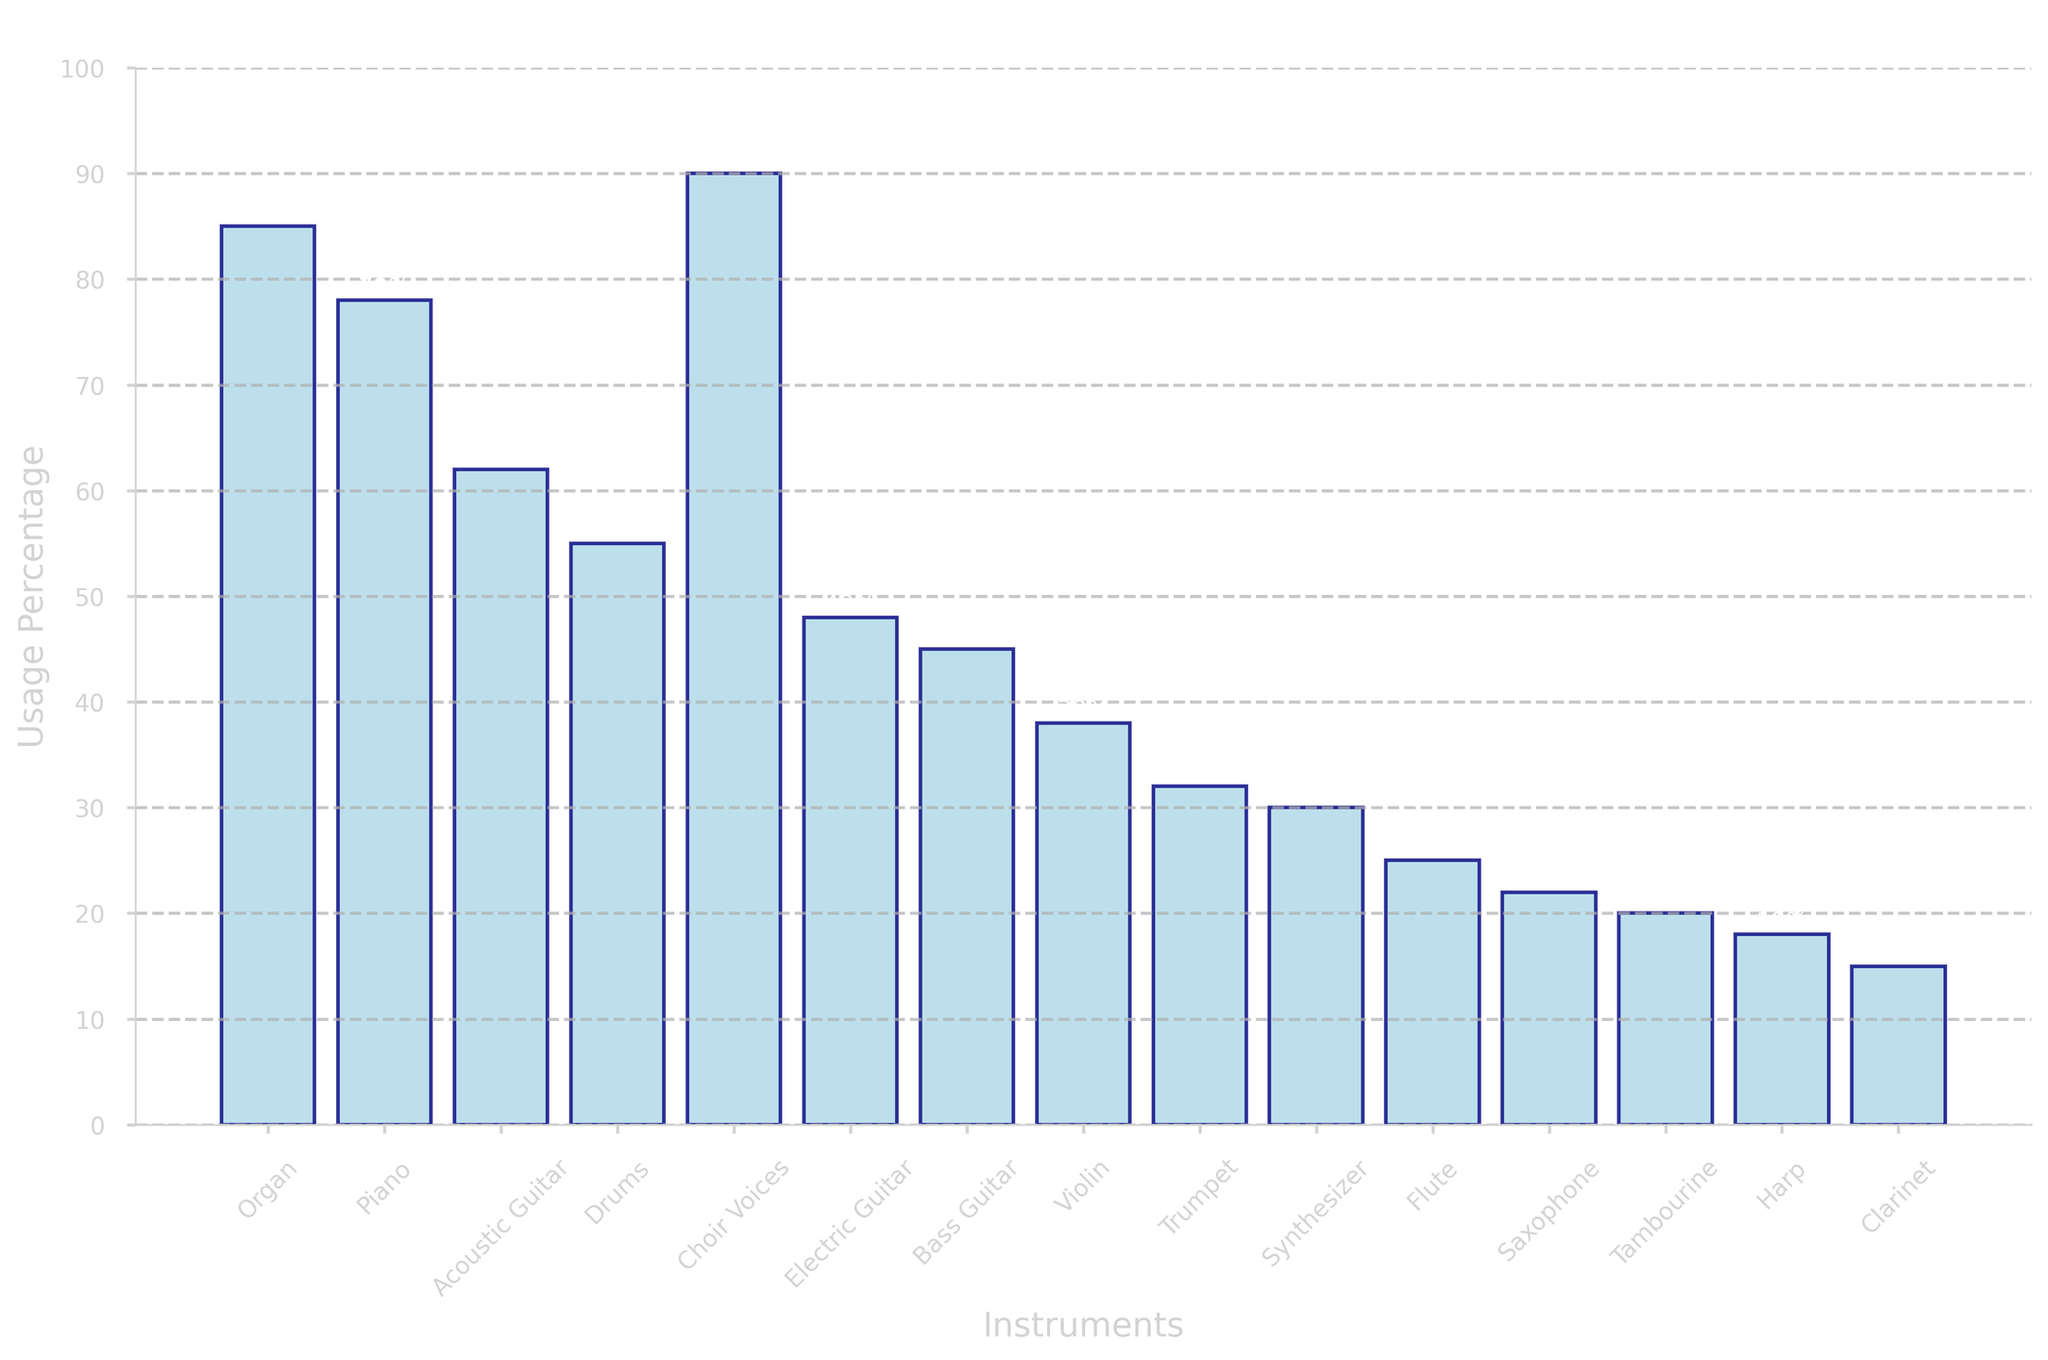What's the most commonly used instrument in church music? The tallest bar represents Choir Voices with a usage percentage of 90%, making it the most commonly used instrument.
Answer: Choir Voices Which instrument is least used in church music? The shortest bar represents the Clarinet with a usage percentage of 15%, indicating that it is the least used instrument.
Answer: Clarinet How much more common is the Organ than the Harp? The usage percentage for the Organ is 85%, while for the Harp it is 18%. The difference between them is 85% - 18% = 67%.
Answer: 67% Are Trumpets used more frequently than Synthesizers? The bar for Trumpet shows a usage percentage of 32%, while for Synthesizer it is 30%. Since 32% is greater than 30%, Trumpets are used more frequently.
Answer: Yes What is the combined usage percentage of Acoustic Guitar and Electric Guitar? The usage percentage for Acoustic Guitar is 62% and for Electric Guitar is 48%. Adding them together gives 62% + 48% = 110%.
Answer: 110% Which instrument has a usage percentage closest to the average usage percentage of all instruments? First, calculate the average usage percentage: (85 + 78 + 62 + 55 + 90 + 48 + 45 + 38 + 32 + 30 + 25 + 22 + 20 + 18 + 15) / 15 = 47.67%. Comparing each instrument's usage percentage, Bass Guitar at 45% is closest.
Answer: Bass Guitar How many instruments have a usage percentage greater than 50%? The instruments with usage percentages greater than 50% are: Organ, Piano, Acoustic Guitar, Drums, and Choir Voices. Counting them gives 5 instruments.
Answer: 5 Is the usage percentage of the Violin greater than, less than, or equal to that of the Flute? The bar for Violin shows a usage percentage of 38%, while the bar for Flute shows 25%. Since 38% is greater than 25%, the Violin is used more frequently than the Flute.
Answer: Greater Which three instruments have the highest usage percentages and what are their percentages? The three tallest bars represent Choir Voices (90%), Organ (85%), and Piano (78%).
Answer: Choir Voices: 90%, Organ: 85%, Piano: 78% What is the difference in usage percentage between Drums and Bass Guitar? The usage percentage for Drums is 55% and for Bass Guitar is 45%. The difference is 55% - 45% = 10%.
Answer: 10% 